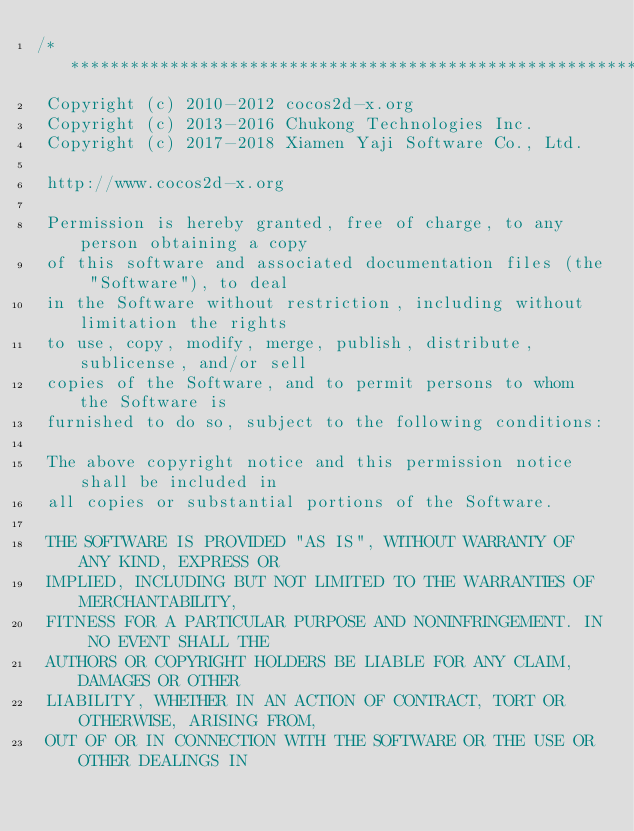<code> <loc_0><loc_0><loc_500><loc_500><_ObjectiveC_>/****************************************************************************
 Copyright (c) 2010-2012 cocos2d-x.org
 Copyright (c) 2013-2016 Chukong Technologies Inc.
 Copyright (c) 2017-2018 Xiamen Yaji Software Co., Ltd.

 http://www.cocos2d-x.org

 Permission is hereby granted, free of charge, to any person obtaining a copy
 of this software and associated documentation files (the "Software"), to deal
 in the Software without restriction, including without limitation the rights
 to use, copy, modify, merge, publish, distribute, sublicense, and/or sell
 copies of the Software, and to permit persons to whom the Software is
 furnished to do so, subject to the following conditions:

 The above copyright notice and this permission notice shall be included in
 all copies or substantial portions of the Software.

 THE SOFTWARE IS PROVIDED "AS IS", WITHOUT WARRANTY OF ANY KIND, EXPRESS OR
 IMPLIED, INCLUDING BUT NOT LIMITED TO THE WARRANTIES OF MERCHANTABILITY,
 FITNESS FOR A PARTICULAR PURPOSE AND NONINFRINGEMENT. IN NO EVENT SHALL THE
 AUTHORS OR COPYRIGHT HOLDERS BE LIABLE FOR ANY CLAIM, DAMAGES OR OTHER
 LIABILITY, WHETHER IN AN ACTION OF CONTRACT, TORT OR OTHERWISE, ARISING FROM,
 OUT OF OR IN CONNECTION WITH THE SOFTWARE OR THE USE OR OTHER DEALINGS IN</code> 